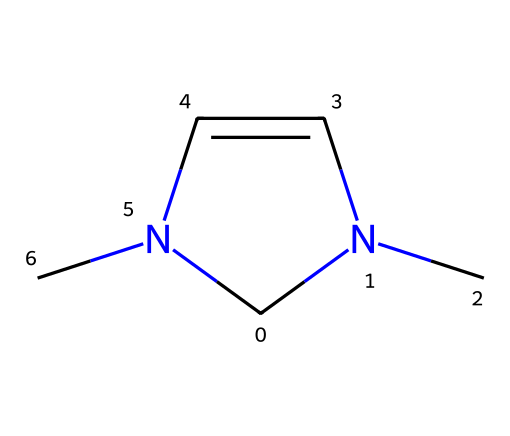What is the total number of nitrogen atoms in this structure? The SMILES representation indicates that there are two nitrogen atoms present within the structure (C1N(C)C=CN1C), as 'N' appears twice.
Answer: 2 How many double bonds are present in this molecule? Analyzing the structure reveals that there is one double bond between the two carbon atoms (C=C), indicated by the '=' in the SMILES string.
Answer: 1 What type of catalyst is represented by this chemical structure? The structure showcases a carbene due to the presence of a divalent carbon atom bonded to both a nitrogen and another carbon.
Answer: carbene Is this molecule likely to be stable under normal conditions? Carbenes, including this structure, are generally considered to be highly reactive and unstable intermediates in organic chemistry, making this molecule likely unstable.
Answer: unstable What cyclic structure is indicated within the molecule? The 'C1' and 'N1' notation in the SMILES implies the presence of a ring, thus this molecule contains a five-membered ring structure involving three carbons and two nitrogens.
Answer: five-membered ring How many carbon atoms are in the entire molecule? By examining the SMILES string, it can be observed that there are four carbon atoms present in the molecule (C1N(C)C=CN1C).
Answer: 4 Is this compound polar or non-polar based on its structure? The presence of multiple electronegative atoms (like nitrogen) suggests a polar character, particularly due to the dipole moments created by the arrangement of atoms in the structure.
Answer: polar 